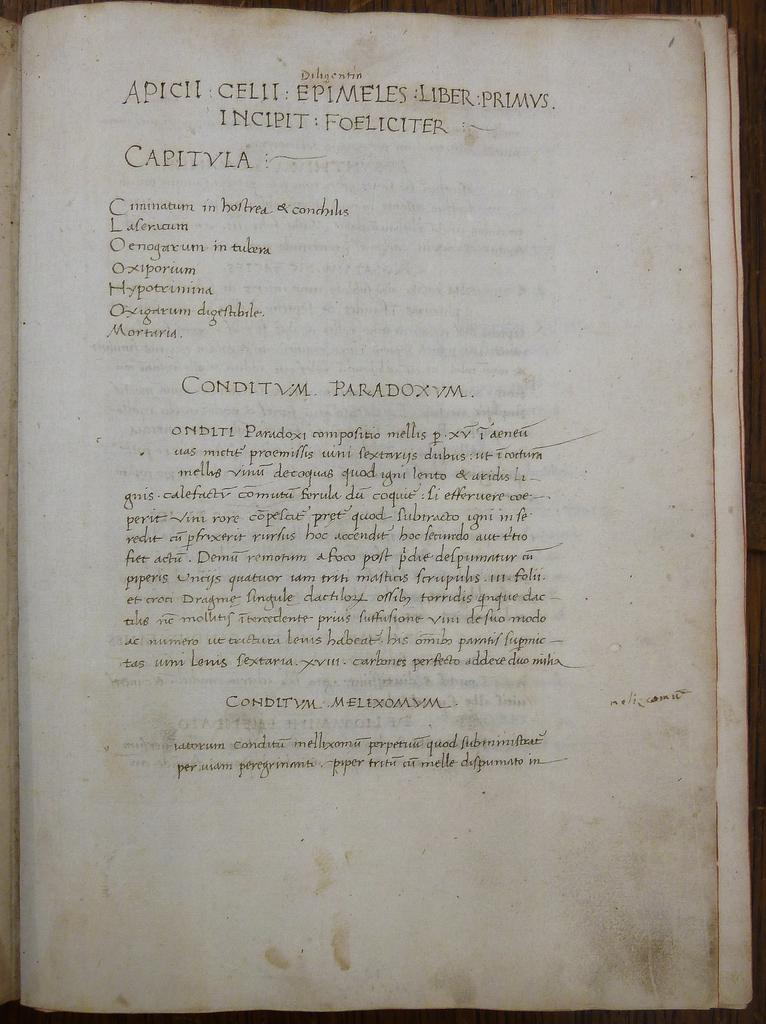<image>
Give a short and clear explanation of the subsequent image. A book about Apicil Celii Epimeles Liber Primvs. 